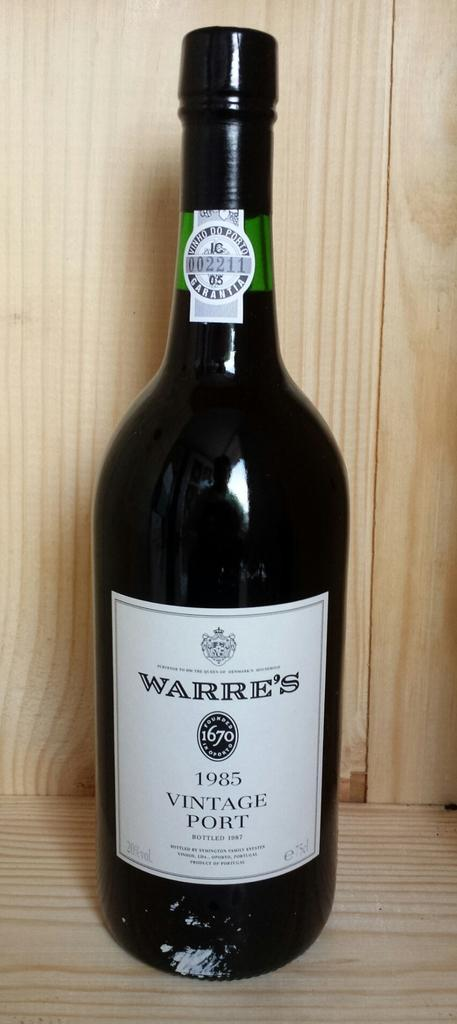Provide a one-sentence caption for the provided image. The brand of wine here is Warre's and is of 1985 vintage. 